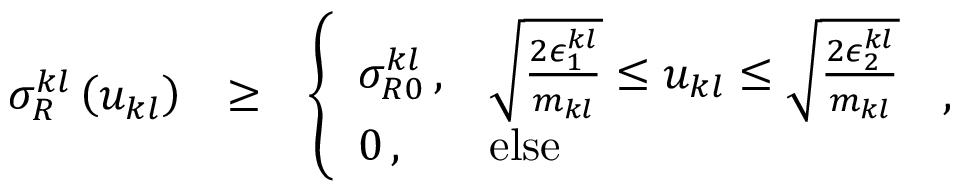Convert formula to latex. <formula><loc_0><loc_0><loc_500><loc_500>\begin{array} { r l r } { \sigma _ { R } ^ { k l } \left ( u _ { k l } \right ) } & { \geq } & { \left \{ \begin{array} { l l } { \sigma _ { R 0 } ^ { k l } \, , } & { \sqrt { \frac { 2 \epsilon _ { 1 } ^ { k l } } { m _ { k l } } } \leq u _ { k l } \leq \sqrt { \frac { 2 \epsilon _ { 2 } ^ { k l } } { m _ { k l } } } } \\ { 0 \, , } & { e l s e } \end{array} \, , } \end{array}</formula> 